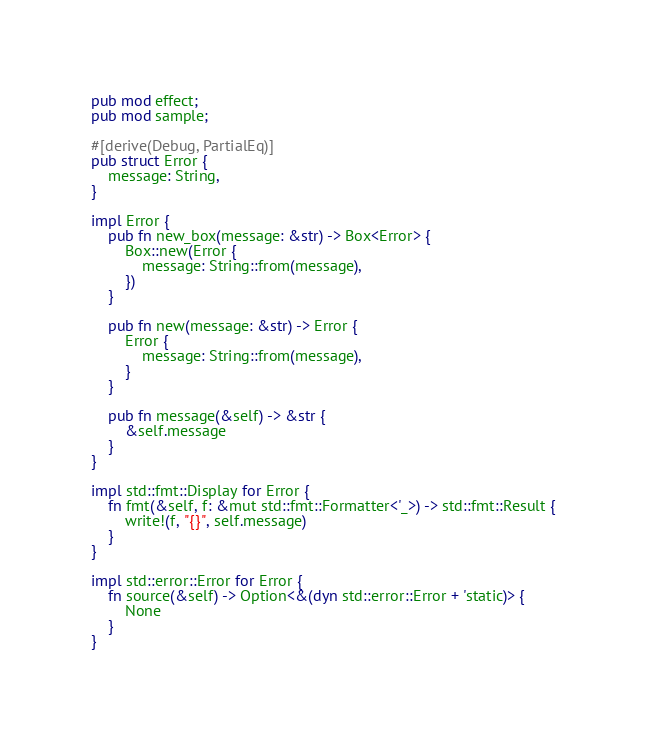<code> <loc_0><loc_0><loc_500><loc_500><_Rust_>pub mod effect;
pub mod sample;

#[derive(Debug, PartialEq)]
pub struct Error {
    message: String,
}

impl Error {
    pub fn new_box(message: &str) -> Box<Error> {
        Box::new(Error {
            message: String::from(message),
        })
    }

    pub fn new(message: &str) -> Error {
        Error {
            message: String::from(message),
        }
    }

    pub fn message(&self) -> &str {
        &self.message
    }
}

impl std::fmt::Display for Error {
    fn fmt(&self, f: &mut std::fmt::Formatter<'_>) -> std::fmt::Result {
        write!(f, "{}", self.message)
    }
}

impl std::error::Error for Error {
    fn source(&self) -> Option<&(dyn std::error::Error + 'static)> {
        None
    }
}
</code> 